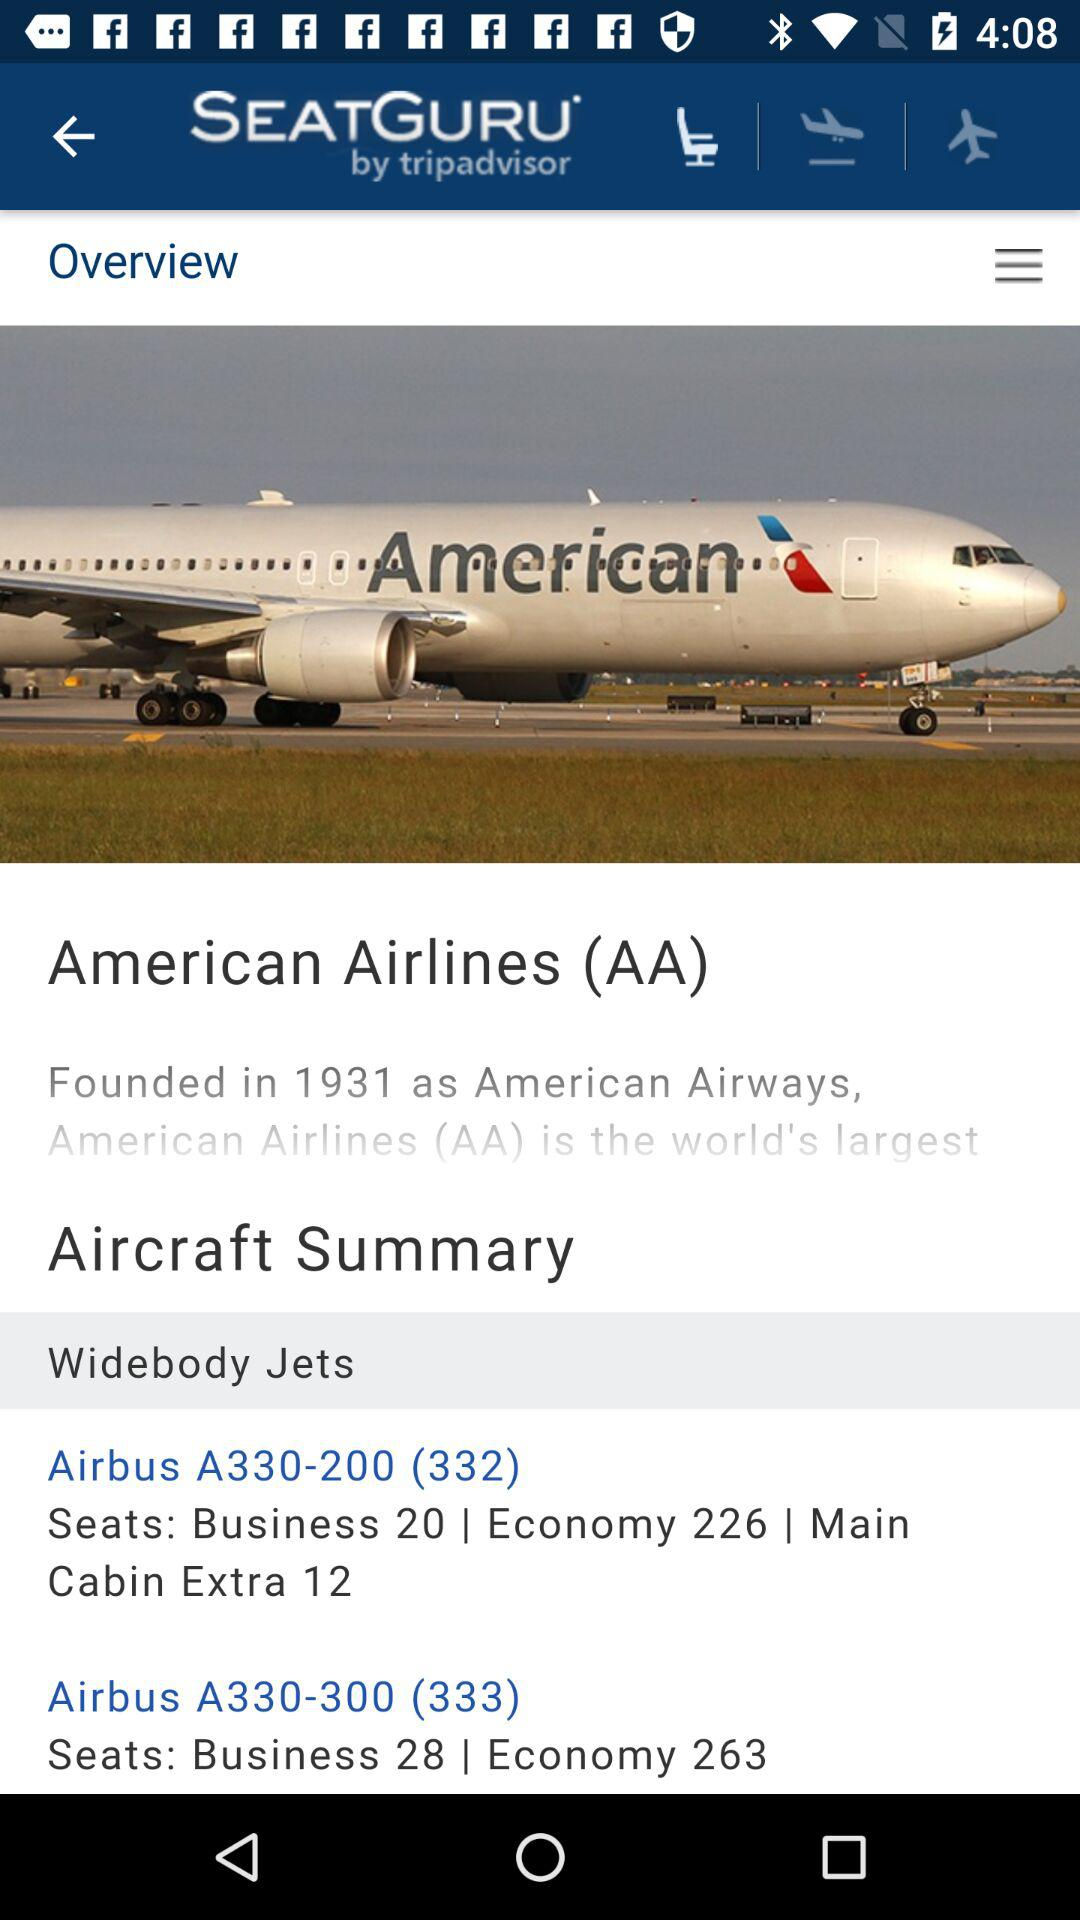When was American Airlines founded? American Airlines was founded in 1931. 